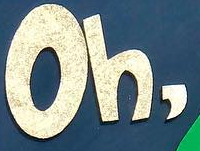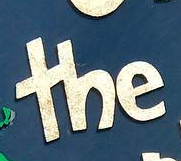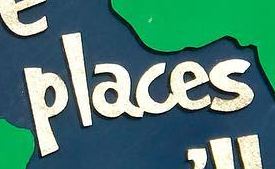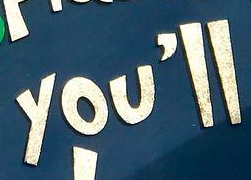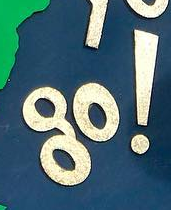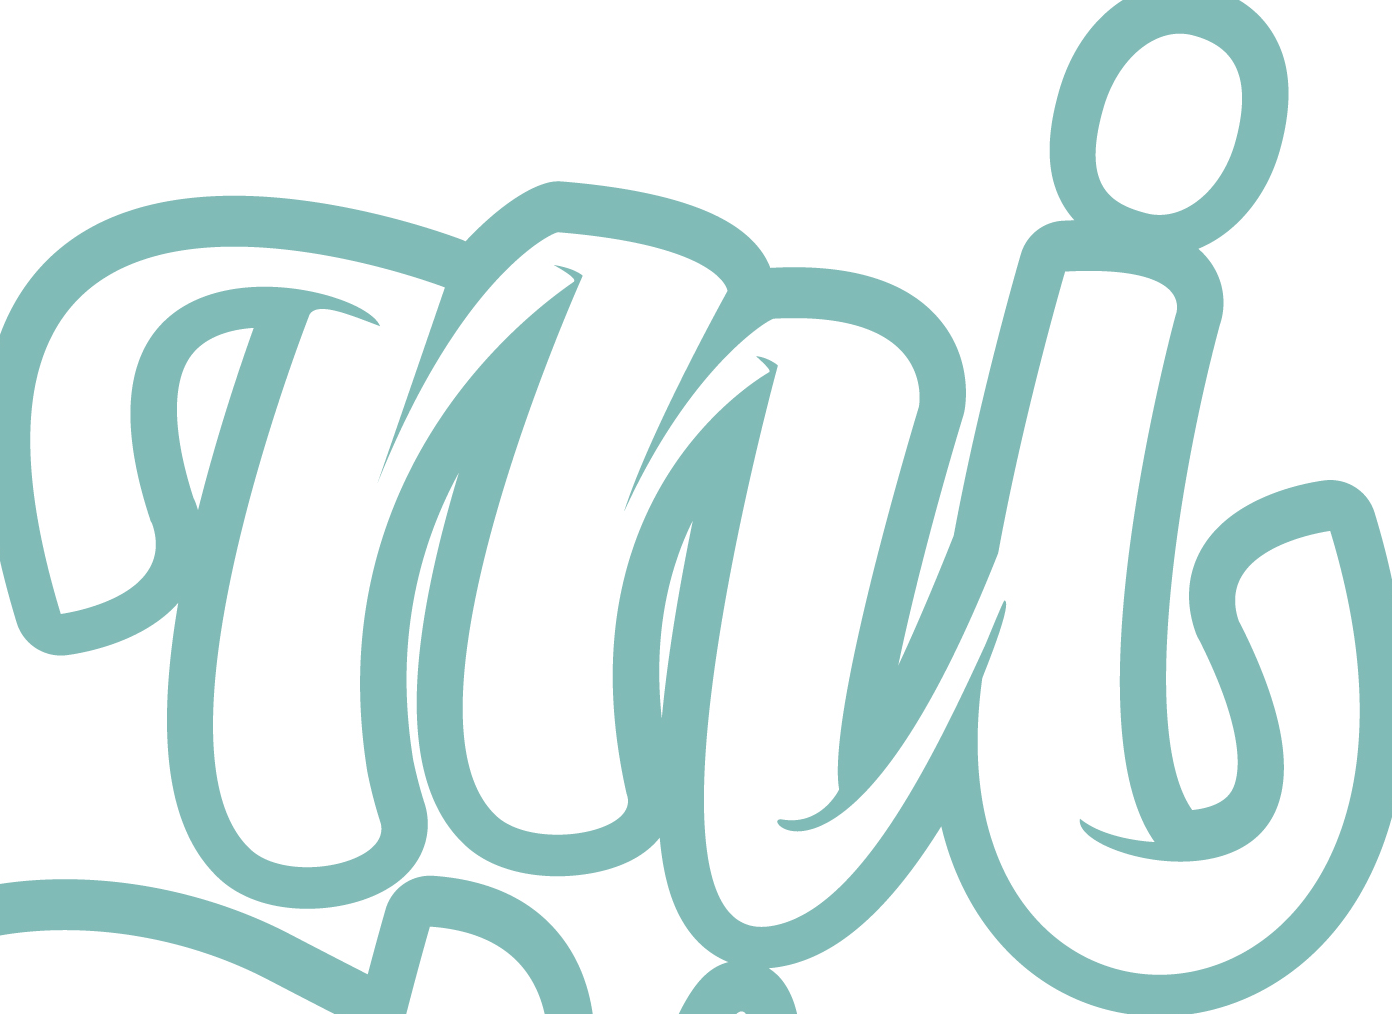Transcribe the words shown in these images in order, separated by a semicolon. Oh,; the; places; you'll; go!; mi 